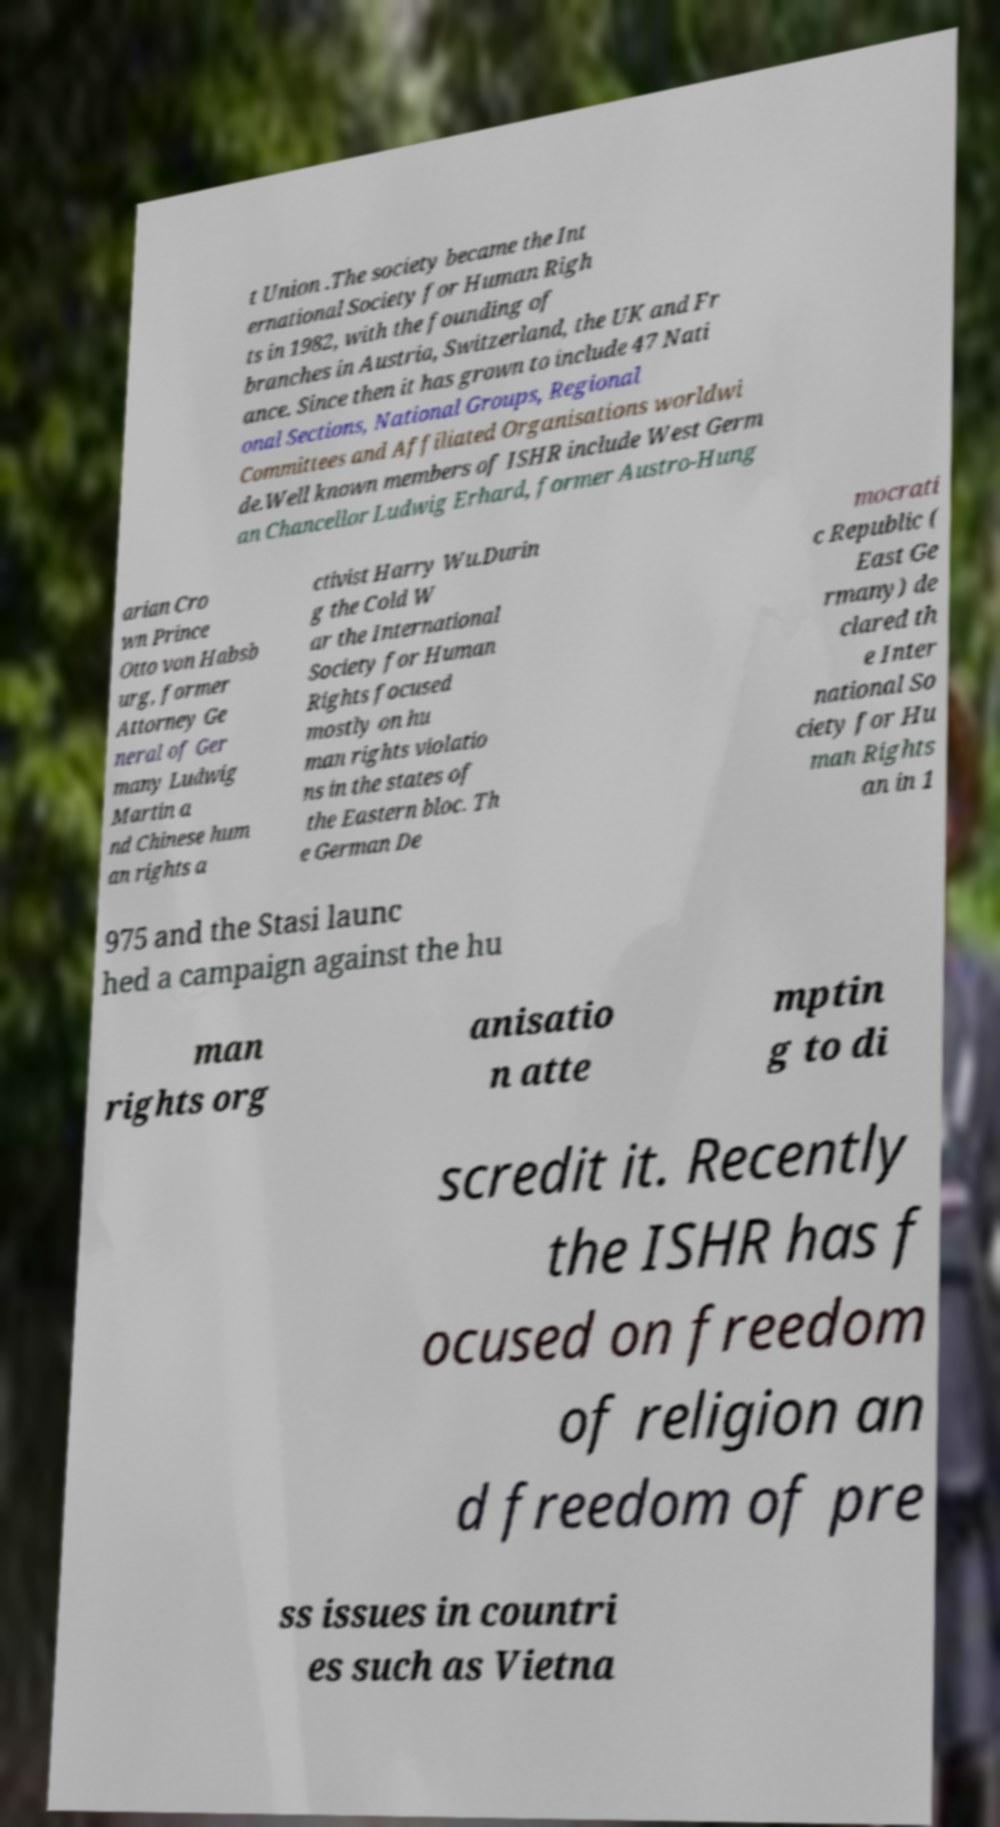Can you read and provide the text displayed in the image?This photo seems to have some interesting text. Can you extract and type it out for me? t Union .The society became the Int ernational Society for Human Righ ts in 1982, with the founding of branches in Austria, Switzerland, the UK and Fr ance. Since then it has grown to include 47 Nati onal Sections, National Groups, Regional Committees and Affiliated Organisations worldwi de.Well known members of ISHR include West Germ an Chancellor Ludwig Erhard, former Austro-Hung arian Cro wn Prince Otto von Habsb urg, former Attorney Ge neral of Ger many Ludwig Martin a nd Chinese hum an rights a ctivist Harry Wu.Durin g the Cold W ar the International Society for Human Rights focused mostly on hu man rights violatio ns in the states of the Eastern bloc. Th e German De mocrati c Republic ( East Ge rmany) de clared th e Inter national So ciety for Hu man Rights an in 1 975 and the Stasi launc hed a campaign against the hu man rights org anisatio n atte mptin g to di scredit it. Recently the ISHR has f ocused on freedom of religion an d freedom of pre ss issues in countri es such as Vietna 